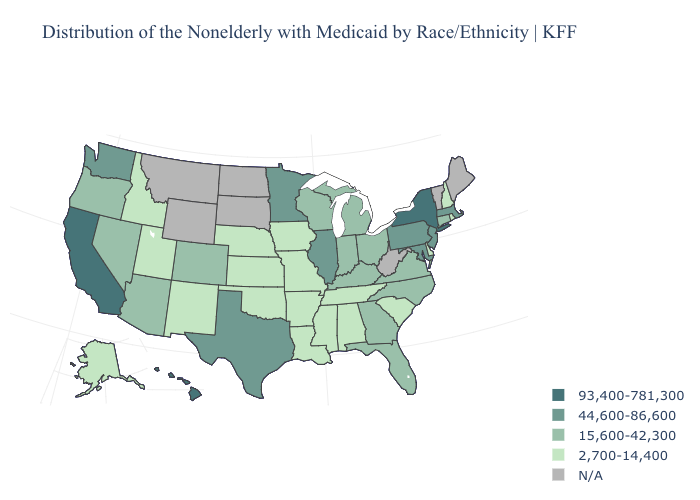Which states have the lowest value in the West?
Concise answer only. Alaska, Idaho, New Mexico, Utah. What is the value of Georgia?
Write a very short answer. 15,600-42,300. Does Georgia have the lowest value in the South?
Write a very short answer. No. What is the value of Utah?
Short answer required. 2,700-14,400. What is the value of Indiana?
Concise answer only. 15,600-42,300. What is the value of Montana?
Answer briefly. N/A. What is the value of Colorado?
Concise answer only. 15,600-42,300. Name the states that have a value in the range 15,600-42,300?
Concise answer only. Arizona, Colorado, Connecticut, Florida, Georgia, Indiana, Kentucky, Michigan, Nevada, North Carolina, Ohio, Oregon, Virginia, Wisconsin. What is the value of North Carolina?
Be succinct. 15,600-42,300. Among the states that border Michigan , which have the highest value?
Write a very short answer. Indiana, Ohio, Wisconsin. What is the value of California?
Short answer required. 93,400-781,300. Among the states that border Utah , which have the highest value?
Short answer required. Arizona, Colorado, Nevada. Is the legend a continuous bar?
Keep it brief. No. What is the highest value in the Northeast ?
Quick response, please. 93,400-781,300. 